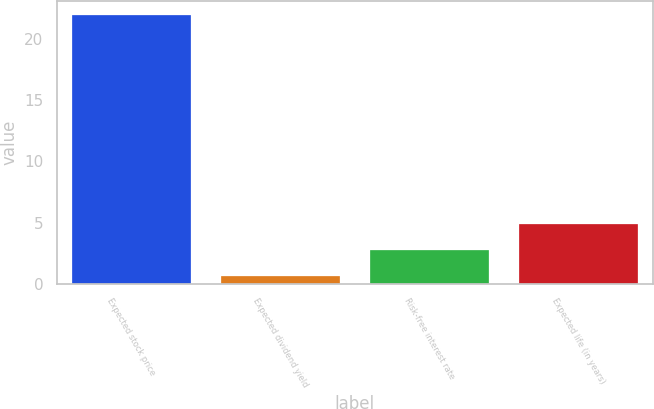Convert chart to OTSL. <chart><loc_0><loc_0><loc_500><loc_500><bar_chart><fcel>Expected stock price<fcel>Expected dividend yield<fcel>Risk-free interest rate<fcel>Expected life (in years)<nl><fcel>22<fcel>0.6<fcel>2.74<fcel>4.88<nl></chart> 